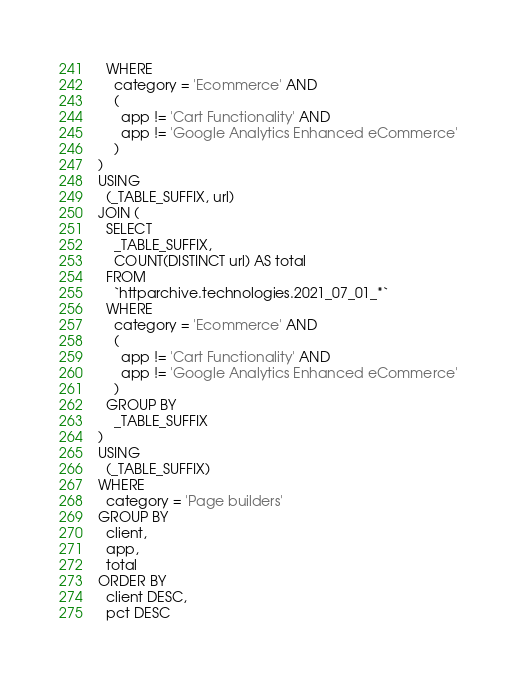<code> <loc_0><loc_0><loc_500><loc_500><_SQL_>  WHERE
    category = 'Ecommerce' AND
    (
      app != 'Cart Functionality' AND
      app != 'Google Analytics Enhanced eCommerce'
    )
)
USING
  (_TABLE_SUFFIX, url)
JOIN (
  SELECT
    _TABLE_SUFFIX,
    COUNT(DISTINCT url) AS total
  FROM
    `httparchive.technologies.2021_07_01_*`
  WHERE
    category = 'Ecommerce' AND
    (
      app != 'Cart Functionality' AND
      app != 'Google Analytics Enhanced eCommerce'
    )
  GROUP BY
    _TABLE_SUFFIX
)
USING
  (_TABLE_SUFFIX)
WHERE
  category = 'Page builders'
GROUP BY
  client,
  app,
  total
ORDER BY
  client DESC,
  pct DESC
</code> 